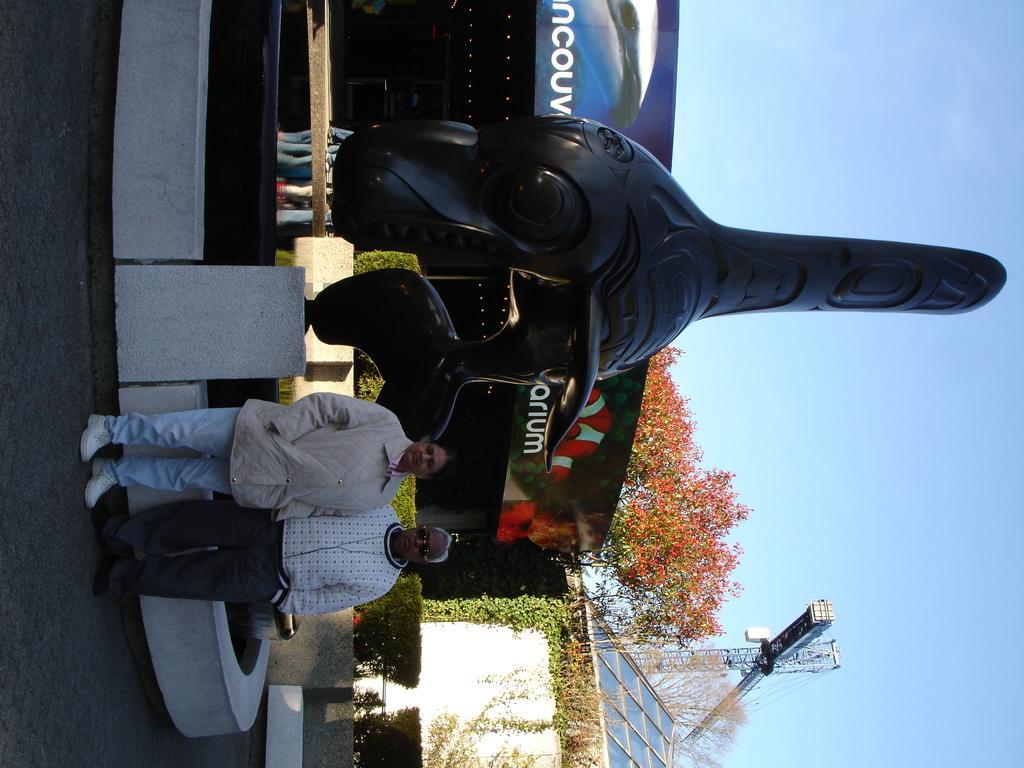In one or two sentences, can you explain what this image depicts? There is a man and woman standing. In the back there is a statue on a stand. In the back there is a building with banner. Also there are trees. In the back there is sky. And there is a tower crane. 